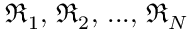Convert formula to latex. <formula><loc_0><loc_0><loc_500><loc_500>\mathfrak { R } _ { 1 } , \, \mathfrak { R } _ { 2 } , \, \dots , \, \mathfrak { R } _ { N }</formula> 